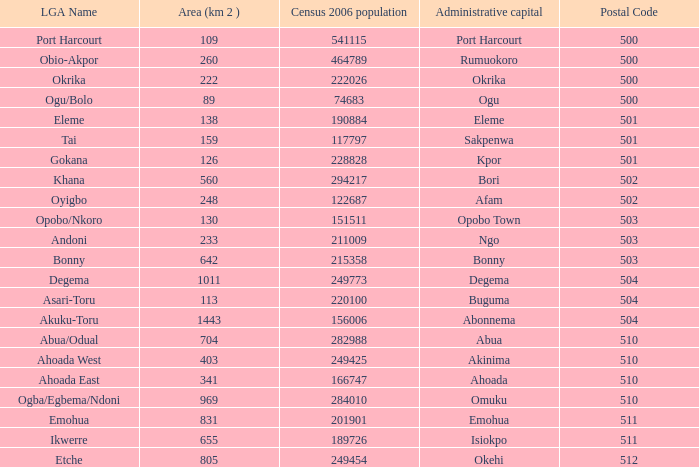What is the 2006 censusn population when is the administrative capital is Eleme? 1.0. 